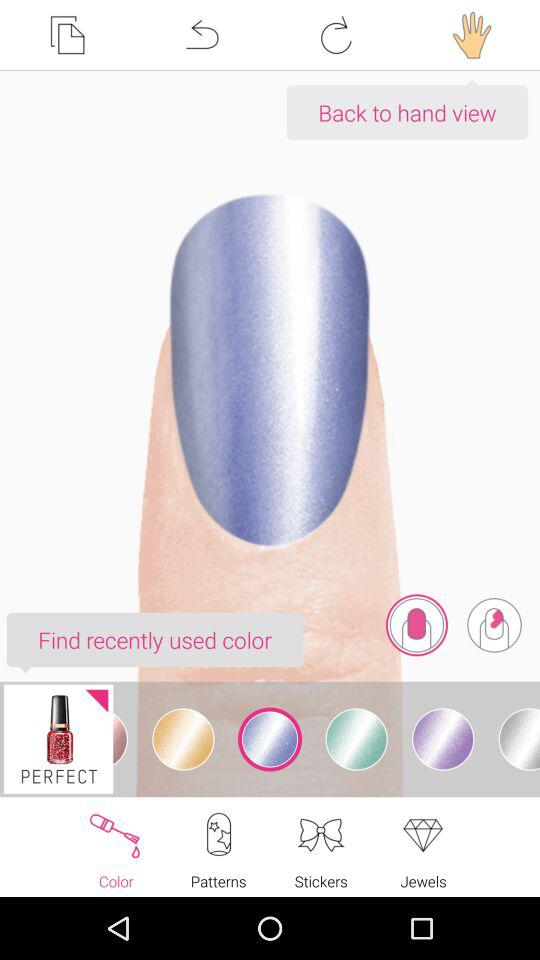Which tab is selected? The selected tab is "Color". 